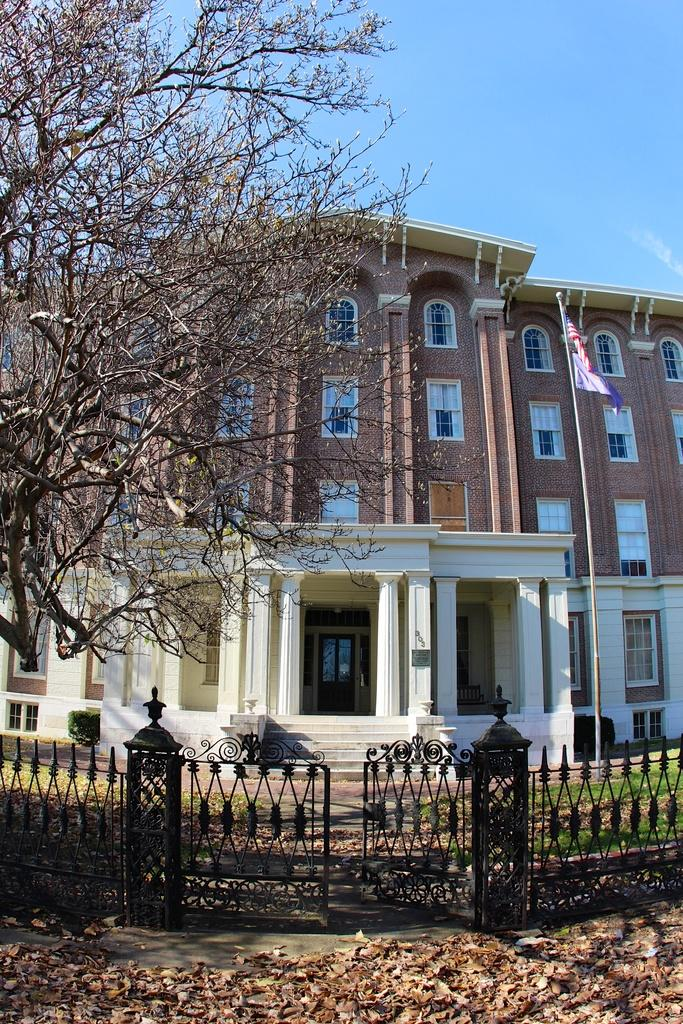What type of plant can be seen in the image? There is a tree in the image. What type of structure is present in the image? There is a gate in the image. What type of barrier surrounds the area in the image? There is a fence in the image. What type of man-made structure is visible in the image? There is a building in the image. What type of natural debris can be seen at the bottom of the image? Dry leaves are present at the bottom of the image. What color is the sky in the image? The sky is blue in color. Where is the flag located in the image? There is a flag on the right side of the image. Can you tell me how many people are lifting the tree in the image? There are no people lifting the tree in the image; it is standing on its own. What type of request can be seen written on the flag in the image? There is no request visible on the flag in the image; it is just a flag. 